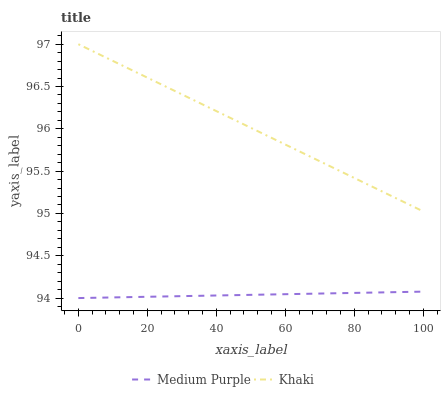Does Medium Purple have the minimum area under the curve?
Answer yes or no. Yes. Does Khaki have the maximum area under the curve?
Answer yes or no. Yes. Does Khaki have the minimum area under the curve?
Answer yes or no. No. Is Medium Purple the smoothest?
Answer yes or no. Yes. Is Khaki the roughest?
Answer yes or no. Yes. Is Khaki the smoothest?
Answer yes or no. No. Does Medium Purple have the lowest value?
Answer yes or no. Yes. Does Khaki have the lowest value?
Answer yes or no. No. Does Khaki have the highest value?
Answer yes or no. Yes. Is Medium Purple less than Khaki?
Answer yes or no. Yes. Is Khaki greater than Medium Purple?
Answer yes or no. Yes. Does Medium Purple intersect Khaki?
Answer yes or no. No. 